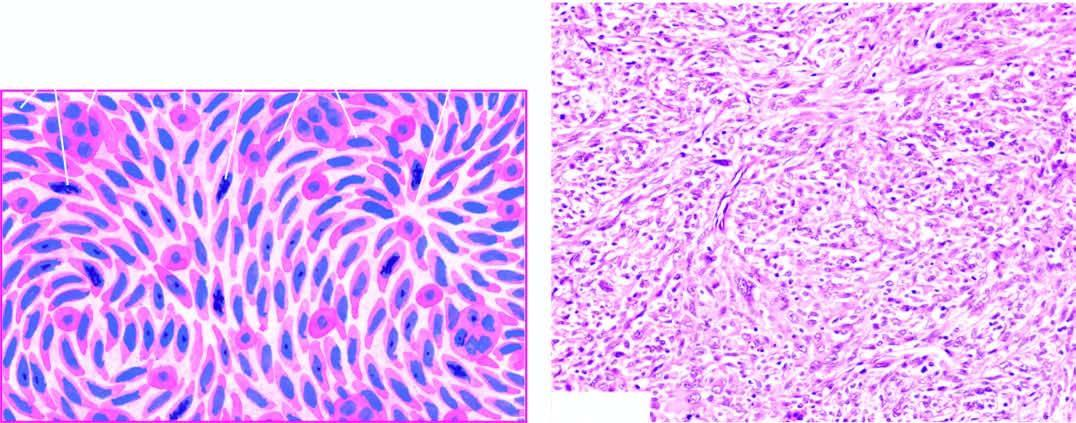what does the tumour show?
Answer the question using a single word or phrase. Admixture of spindle-shaped pleomorphic cells forming storiform pattern and histiocyte-like round to oval cells 